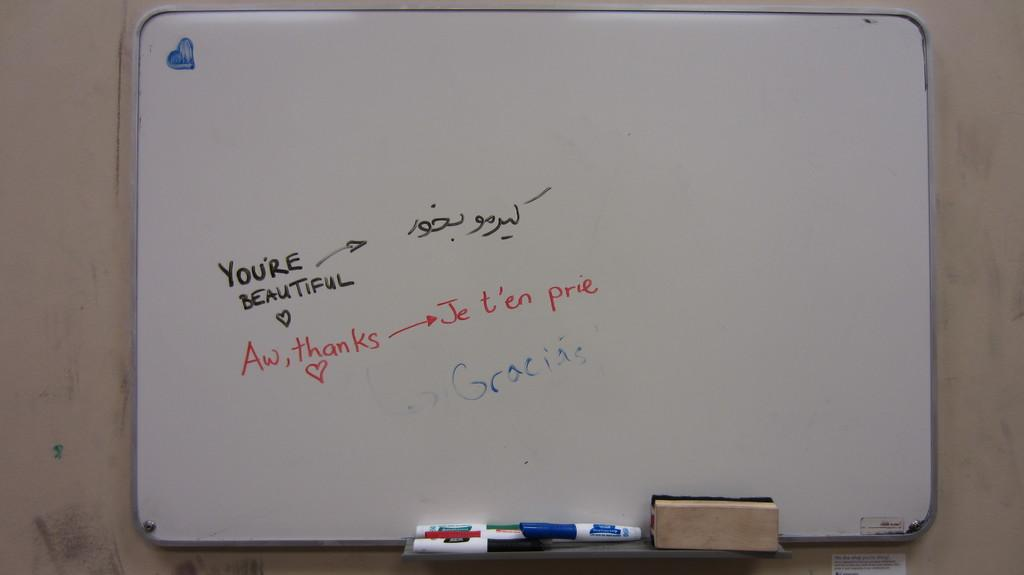<image>
Share a concise interpretation of the image provided. White board that says "You're Beautiful" in black. 